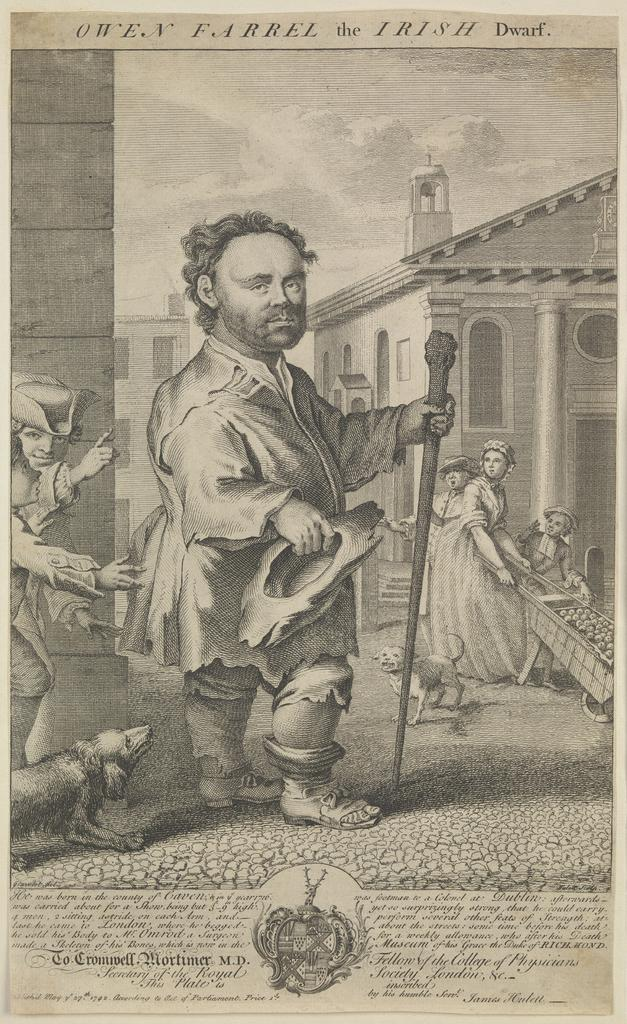What type of artwork is depicted in the image? The image is a painting. What can be seen in the painting? There is a group of people in the painting. What is visible in the background of the painting? There are buildings in the background of the painting. What flavor of ice cream do the people in the painting believe is the best? There is no mention of ice cream or beliefs in the image, so it cannot be determined from the painting. 